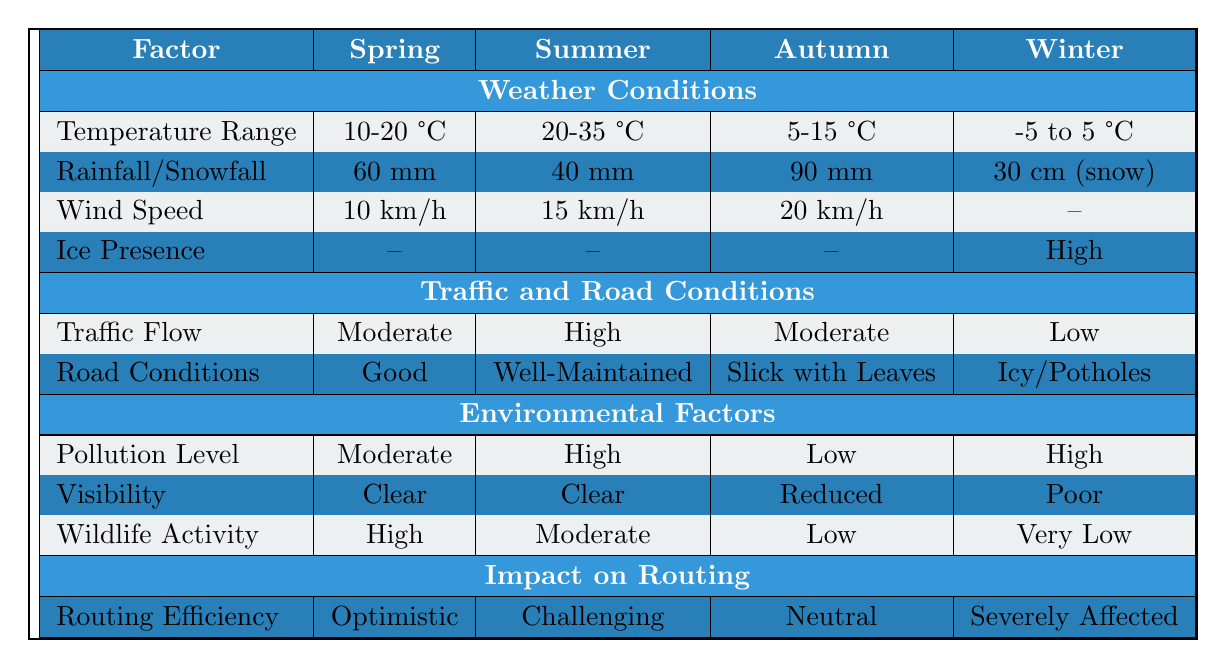What is the impact on routing efficiency in winter? The table shows that in winter, the impact on routing efficiency is labeled as "Severely Affected," indicating significant challenges in routing.
Answer: Severely Affected Which season has the highest rainfall? Looking at the rainfall values for each season in the table, autumn shows the highest rainfall at 90 mm when compared to spring at 60 mm, summer at 40 mm, and winter at 30 cm (which is approximately 300 mm for comparison).
Answer: Autumn What is the temperature range during summer? The table states that the temperature range in summer is 20 to 35 °C, indicating relatively warm conditions during this season.
Answer: 20-35 °C How does wildlife activity change from spring to winter? In spring, wildlife activity is high, while in winter, it is very low. This indicates a decrease in wildlife activity from spring to winter.
Answer: Decrease Which season has the best road conditions? From the road conditions listed in the table, summer has "Well-Maintained" conditions, which is the most favorable compared to other seasons that describe varying issues such as icy conditions or slickness.
Answer: Summer Is the visibility in summer better than in autumn? The visibility in summer is noted as "Clear," while in autumn it is described as "Reduced," thereby confirming that visibility in summer is indeed better than in autumn.
Answer: Yes What factor regarding pollution is highest in summer? The table indicates a "High" pollution level in summer, which is the highest among the seasons provided.
Answer: High Which season has the lowest temperature range? The winter season has the lowest temperature range of -5 to 5 °C, which is lower than the other seasons listed.
Answer: Winter What is the average wind speed across all seasons? The wind speeds are 10 km/h (spring), 15 km/h (summer), 20 km/h (autumn), and there is no data for winter. Thus, the average is calculated as (10 + 15 + 20) / 3 = 15 km/h.
Answer: 15 km/h If the traffic flow is low, which season does it correspond to? The table indicates that low traffic flow corresponds to winter, where traffic flow is described as "Low."
Answer: Winter Which season has the worst impact on routing efficiency and why? The worst impact on routing efficiency is in winter, described as "Severely Affected," indicating extreme challenges due to weather conditions such as ice and low traffic flow.
Answer: Winter due to severe impact How does the road condition of autumn compare to winter? Autumn has a "Slick with Leaves" road condition, whereas winter has "Icy/Potholes," with winter being generally worse due to ice issues.
Answer: Winter is worse In which season is the wildlife activity the highest? The table states that wildlife activity is labeled as "High" in spring, which is the highest compared to other seasons.
Answer: Spring What is the snowfall amount in winter? The table shows that winter has a snowfall amount of 30 cm, indicating severe weather conditions.
Answer: 30 cm What is the difference in pollution levels between summer and autumn? In summer, the pollution level is "High" while in autumn it is "Low." The difference indicates a change from high to low, which is notable for routing considerations.
Answer: High (difference from High to Low) What season experiences the least wind speed? Spring experiences the least wind speed at 10 km/h, compared to the higher wind speeds reported for other seasons as per the table.
Answer: Spring 